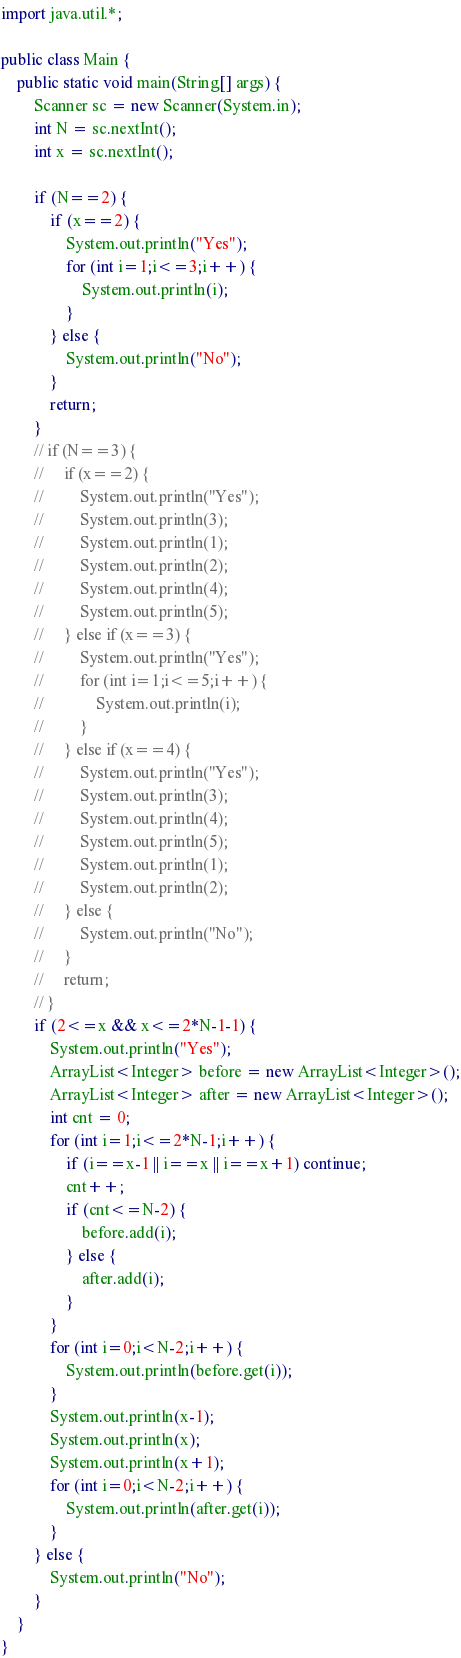<code> <loc_0><loc_0><loc_500><loc_500><_Java_>import java.util.*;

public class Main {
    public static void main(String[] args) {
        Scanner sc = new Scanner(System.in);
        int N = sc.nextInt();
        int x = sc.nextInt();

        if (N==2) {
            if (x==2) {
                System.out.println("Yes");
                for (int i=1;i<=3;i++) {
                    System.out.println(i);
                }
            } else {
                System.out.println("No");
            }
            return;
        }
        // if (N==3) {
        //     if (x==2) {
        //         System.out.println("Yes");
        //         System.out.println(3);
        //         System.out.println(1);
        //         System.out.println(2);
        //         System.out.println(4);
        //         System.out.println(5);
        //     } else if (x==3) {
        //         System.out.println("Yes");
        //         for (int i=1;i<=5;i++) {
        //             System.out.println(i);
        //         }
        //     } else if (x==4) {
        //         System.out.println("Yes");
        //         System.out.println(3);
        //         System.out.println(4);
        //         System.out.println(5);
        //         System.out.println(1);
        //         System.out.println(2);
        //     } else {
        //         System.out.println("No");
        //     }
        //     return;
        // }
        if (2<=x && x<=2*N-1-1) {
            System.out.println("Yes");
            ArrayList<Integer> before = new ArrayList<Integer>();
            ArrayList<Integer> after = new ArrayList<Integer>();
            int cnt = 0;
            for (int i=1;i<=2*N-1;i++) {
                if (i==x-1 || i==x || i==x+1) continue;
                cnt++;
                if (cnt<=N-2) {
                    before.add(i);
                } else {
                    after.add(i);
                }
            }
            for (int i=0;i<N-2;i++) {
                System.out.println(before.get(i));
            }
            System.out.println(x-1);
            System.out.println(x);
            System.out.println(x+1);
            for (int i=0;i<N-2;i++) {
                System.out.println(after.get(i));
            }
        } else {
            System.out.println("No");
        }
    }
}</code> 